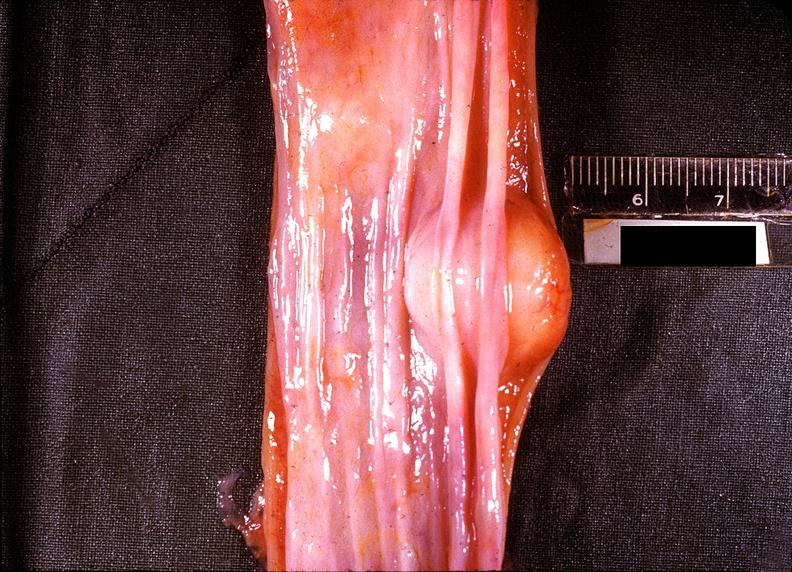s gastrointestinal present?
Answer the question using a single word or phrase. Yes 